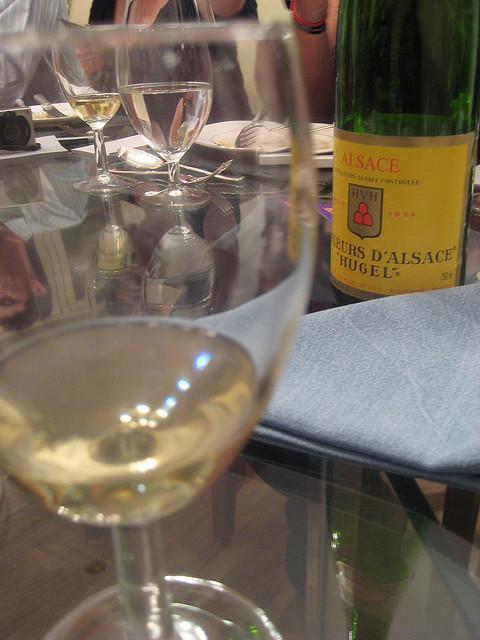How many wine glasses are on the table?
Give a very brief answer. 3. 